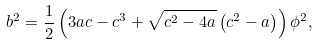<formula> <loc_0><loc_0><loc_500><loc_500>b ^ { 2 } = \frac { 1 } { 2 } \left ( 3 a c - c ^ { 3 } + \sqrt { c ^ { 2 } - 4 a } \left ( c ^ { 2 } - a \right ) \right ) \phi ^ { 2 } ,</formula> 